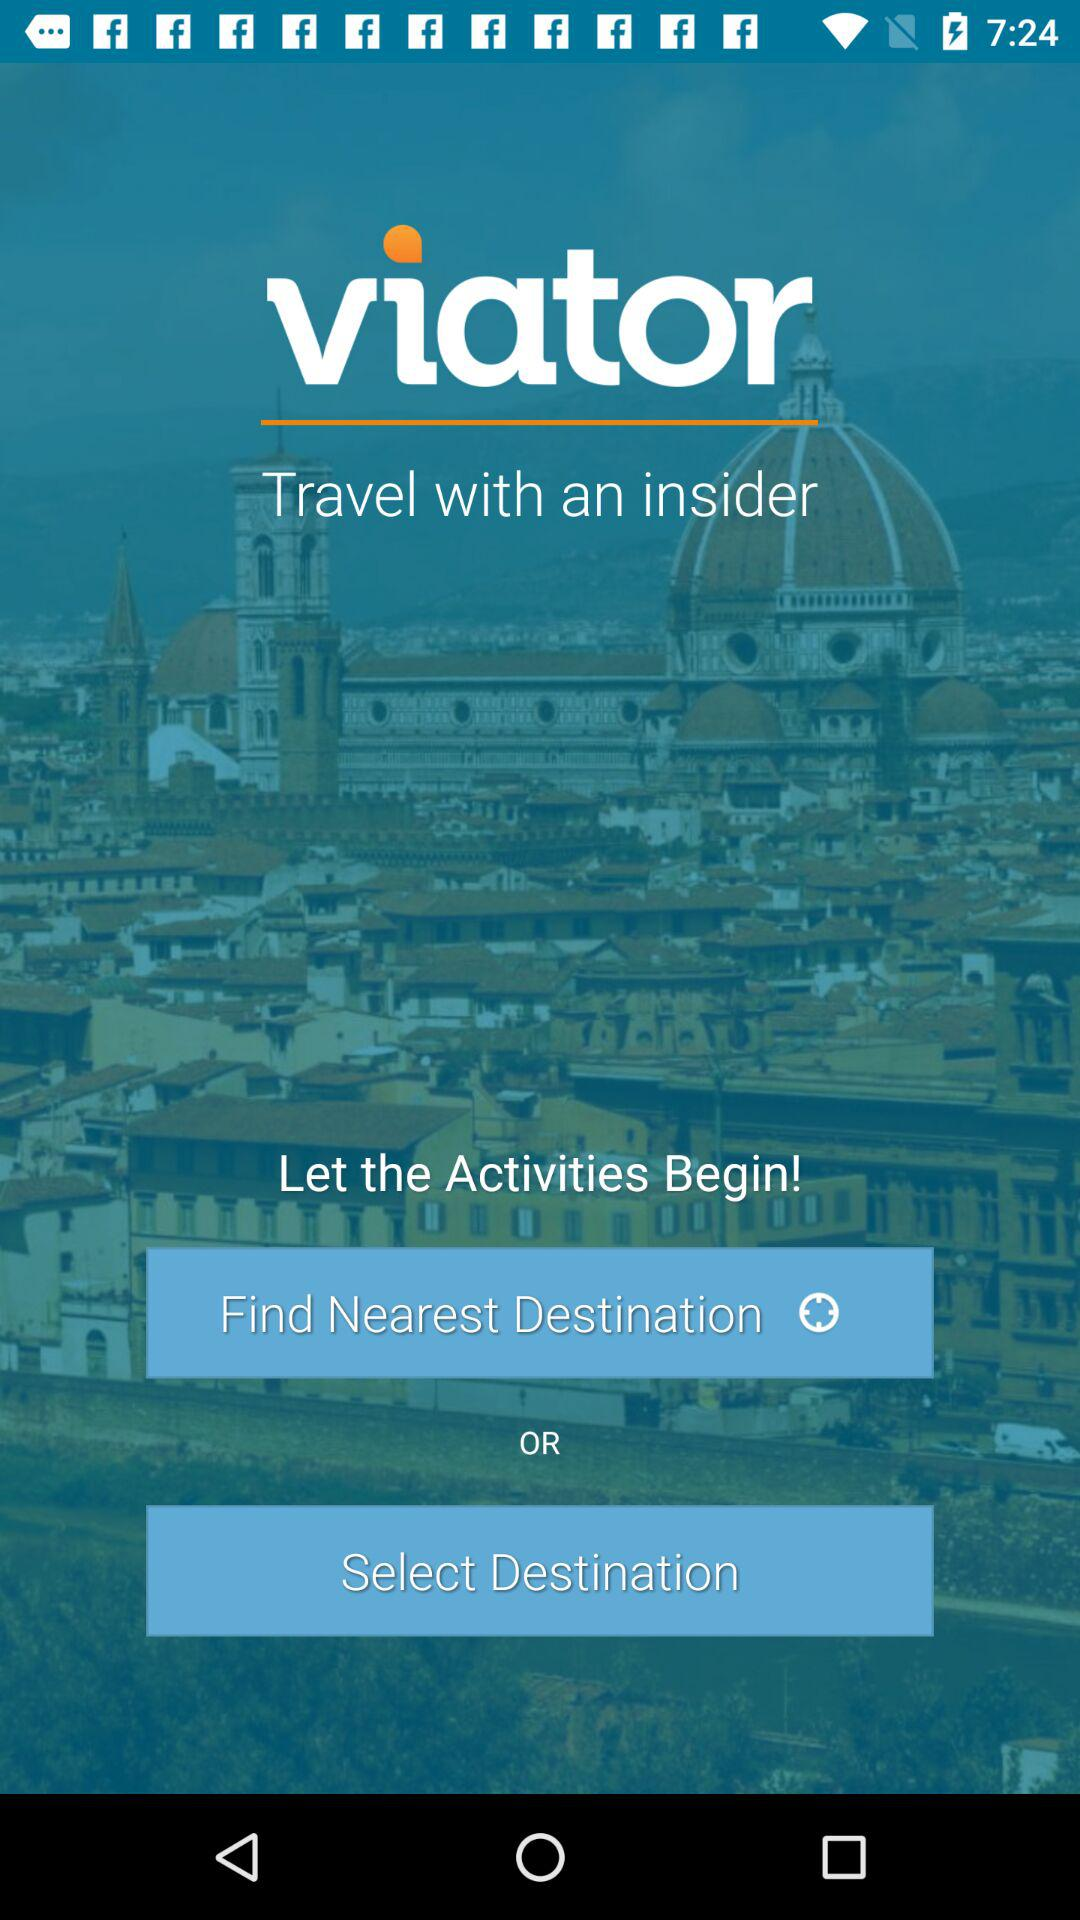What is the application name? The application name is "viator". 